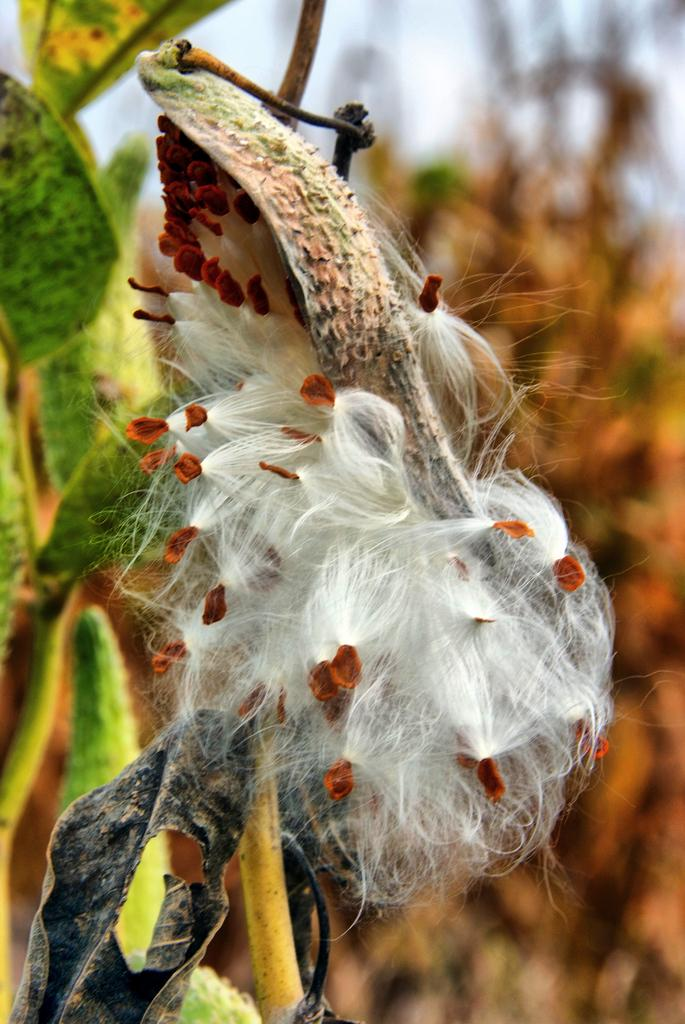What type of plant is in the foreground of the image? There is a cotton plant in the foreground of the image. What type of wave can be seen in the image? There is no wave present in the image; it features a cotton plant in the foreground. What activity is taking place in the image? The image does not depict any specific activity; it simply shows a cotton plant in the foreground. 